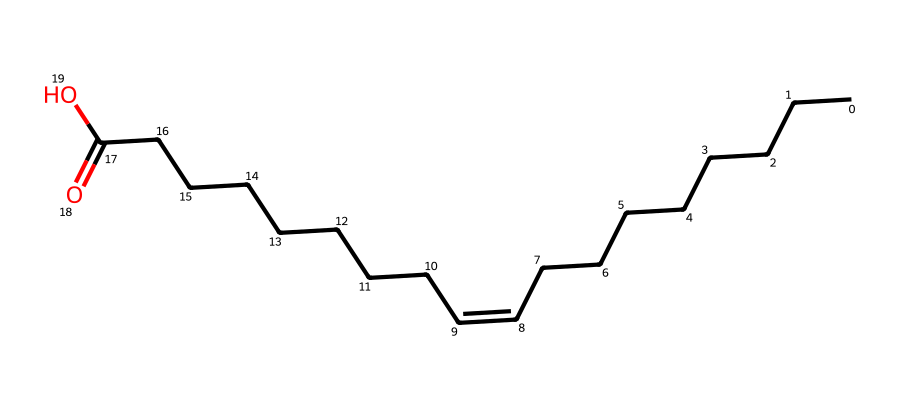What is the name of this chemical? The SMILES representation indicates it is an unsaturated fatty acid based on the presence of a double bond in the carbon chain. The structure matches oleic acid.
Answer: oleic acid How many carbon atoms are in oleic acid? By analyzing the SMILES representation, we can count the carbon atoms. There are a total of 18 carbon atoms in the chain.
Answer: 18 What type of isomerism does oleic acid exhibit? The structure displays a C=C double bond that can have geometrical variations, specifically E-Z isomerism due to the configuration around the double bond.
Answer: E-Z isomerism What are the different configurations of oleic acid? The configurations around the double bond can be either cis (Z) or trans (E). In the case of oleic acid, it is primarily found in the cis configuration.
Answer: cis What functional group is present in oleic acid? Identifying functional groups from the SMILES, the presence of -COOH at the end indicates that it has a carboxylic acid functional group.
Answer: carboxylic acid How does the presence of a double bond affect oleic acid's melting point? The presence of the double bond introduces kinks in the fatty acid chain, preventing tight packing of molecules, which lowers the melting point compared to saturated fatty acids.
Answer: lowers 